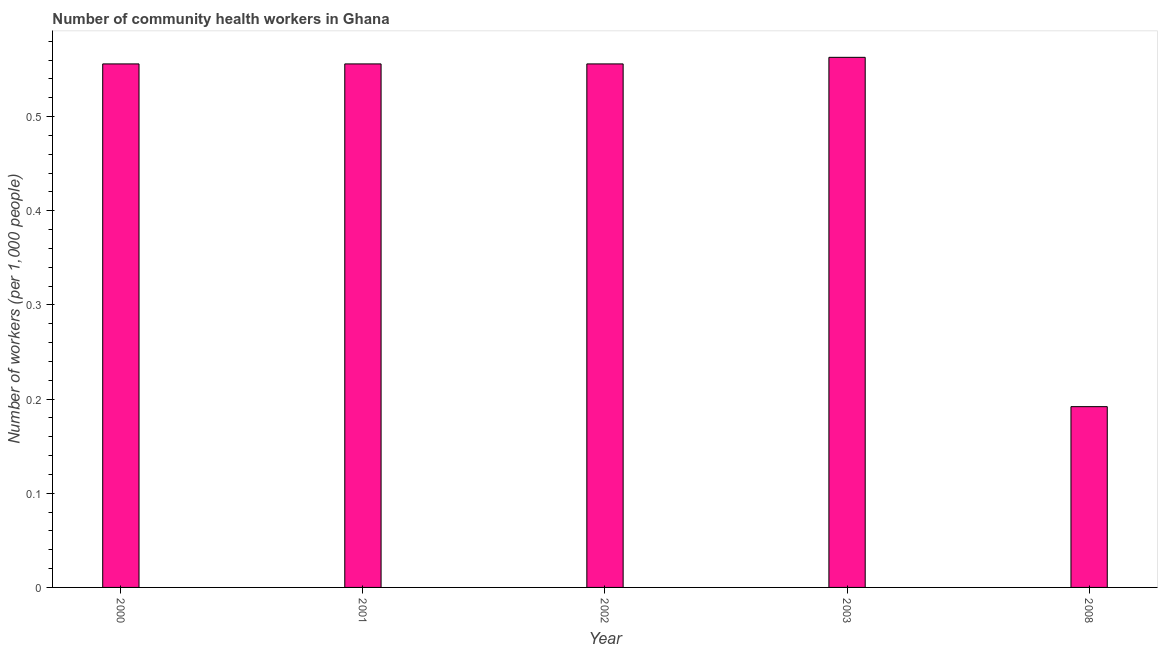What is the title of the graph?
Make the answer very short. Number of community health workers in Ghana. What is the label or title of the Y-axis?
Your answer should be compact. Number of workers (per 1,0 people). What is the number of community health workers in 2002?
Your answer should be compact. 0.56. Across all years, what is the maximum number of community health workers?
Provide a short and direct response. 0.56. Across all years, what is the minimum number of community health workers?
Your response must be concise. 0.19. In which year was the number of community health workers maximum?
Provide a succinct answer. 2003. What is the sum of the number of community health workers?
Your response must be concise. 2.42. What is the average number of community health workers per year?
Your response must be concise. 0.48. What is the median number of community health workers?
Make the answer very short. 0.56. What is the ratio of the number of community health workers in 2002 to that in 2008?
Offer a very short reply. 2.9. Is the number of community health workers in 2002 less than that in 2003?
Provide a succinct answer. Yes. What is the difference between the highest and the second highest number of community health workers?
Keep it short and to the point. 0.01. Is the sum of the number of community health workers in 2002 and 2008 greater than the maximum number of community health workers across all years?
Ensure brevity in your answer.  Yes. What is the difference between the highest and the lowest number of community health workers?
Ensure brevity in your answer.  0.37. In how many years, is the number of community health workers greater than the average number of community health workers taken over all years?
Keep it short and to the point. 4. How many bars are there?
Your response must be concise. 5. Are all the bars in the graph horizontal?
Offer a terse response. No. How many years are there in the graph?
Make the answer very short. 5. What is the Number of workers (per 1,000 people) in 2000?
Provide a short and direct response. 0.56. What is the Number of workers (per 1,000 people) in 2001?
Make the answer very short. 0.56. What is the Number of workers (per 1,000 people) of 2002?
Your answer should be very brief. 0.56. What is the Number of workers (per 1,000 people) in 2003?
Ensure brevity in your answer.  0.56. What is the Number of workers (per 1,000 people) of 2008?
Give a very brief answer. 0.19. What is the difference between the Number of workers (per 1,000 people) in 2000 and 2001?
Provide a short and direct response. 0. What is the difference between the Number of workers (per 1,000 people) in 2000 and 2002?
Provide a succinct answer. 0. What is the difference between the Number of workers (per 1,000 people) in 2000 and 2003?
Offer a terse response. -0.01. What is the difference between the Number of workers (per 1,000 people) in 2000 and 2008?
Offer a terse response. 0.36. What is the difference between the Number of workers (per 1,000 people) in 2001 and 2003?
Offer a terse response. -0.01. What is the difference between the Number of workers (per 1,000 people) in 2001 and 2008?
Your answer should be compact. 0.36. What is the difference between the Number of workers (per 1,000 people) in 2002 and 2003?
Offer a very short reply. -0.01. What is the difference between the Number of workers (per 1,000 people) in 2002 and 2008?
Keep it short and to the point. 0.36. What is the difference between the Number of workers (per 1,000 people) in 2003 and 2008?
Provide a short and direct response. 0.37. What is the ratio of the Number of workers (per 1,000 people) in 2000 to that in 2002?
Your answer should be compact. 1. What is the ratio of the Number of workers (per 1,000 people) in 2000 to that in 2008?
Make the answer very short. 2.9. What is the ratio of the Number of workers (per 1,000 people) in 2001 to that in 2003?
Give a very brief answer. 0.99. What is the ratio of the Number of workers (per 1,000 people) in 2001 to that in 2008?
Make the answer very short. 2.9. What is the ratio of the Number of workers (per 1,000 people) in 2002 to that in 2003?
Make the answer very short. 0.99. What is the ratio of the Number of workers (per 1,000 people) in 2002 to that in 2008?
Your response must be concise. 2.9. What is the ratio of the Number of workers (per 1,000 people) in 2003 to that in 2008?
Provide a succinct answer. 2.93. 